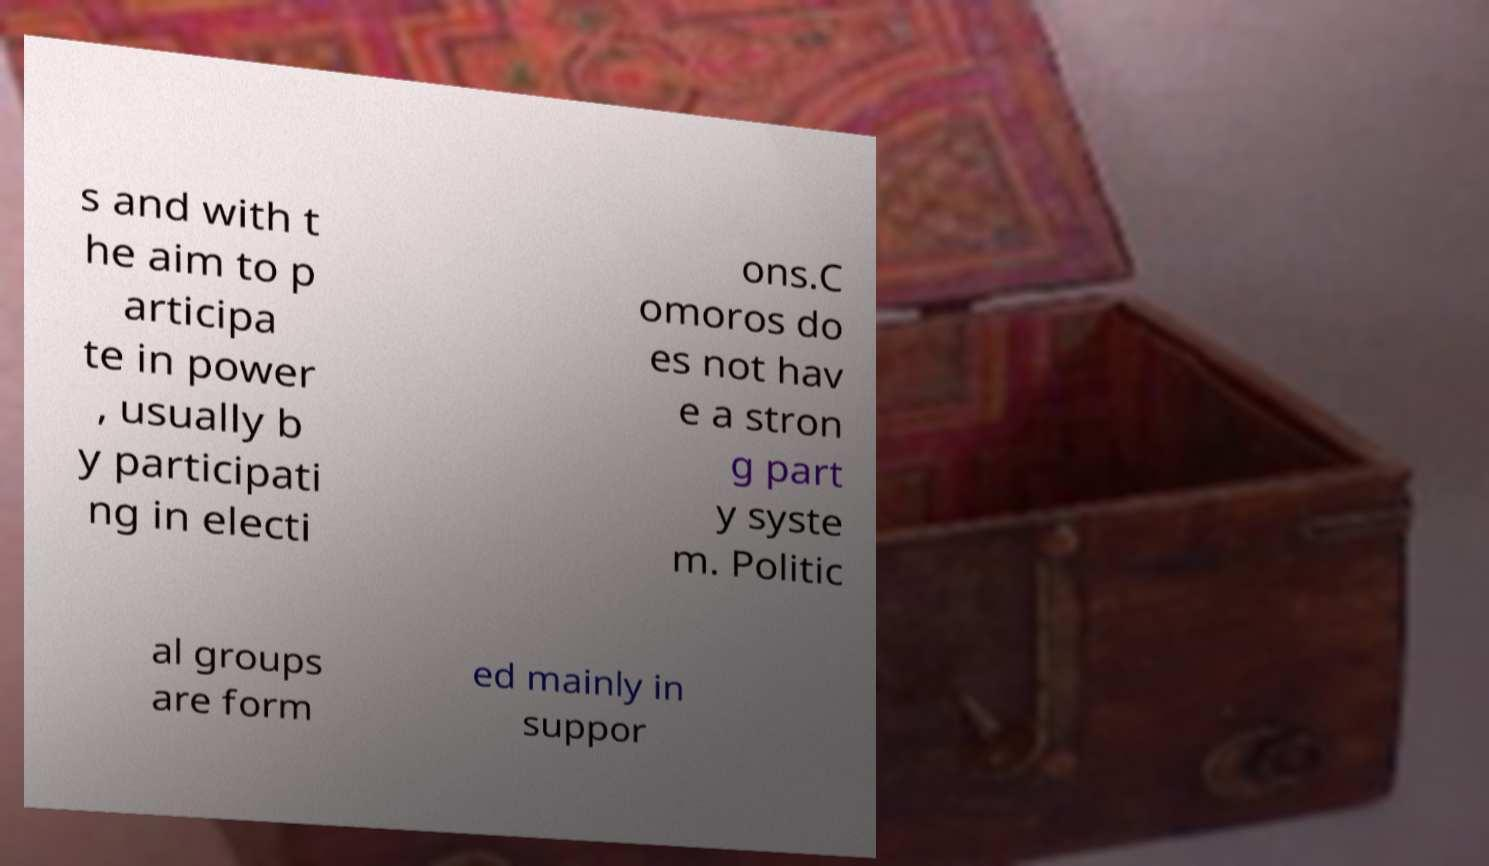Can you read and provide the text displayed in the image?This photo seems to have some interesting text. Can you extract and type it out for me? s and with t he aim to p articipa te in power , usually b y participati ng in electi ons.C omoros do es not hav e a stron g part y syste m. Politic al groups are form ed mainly in suppor 